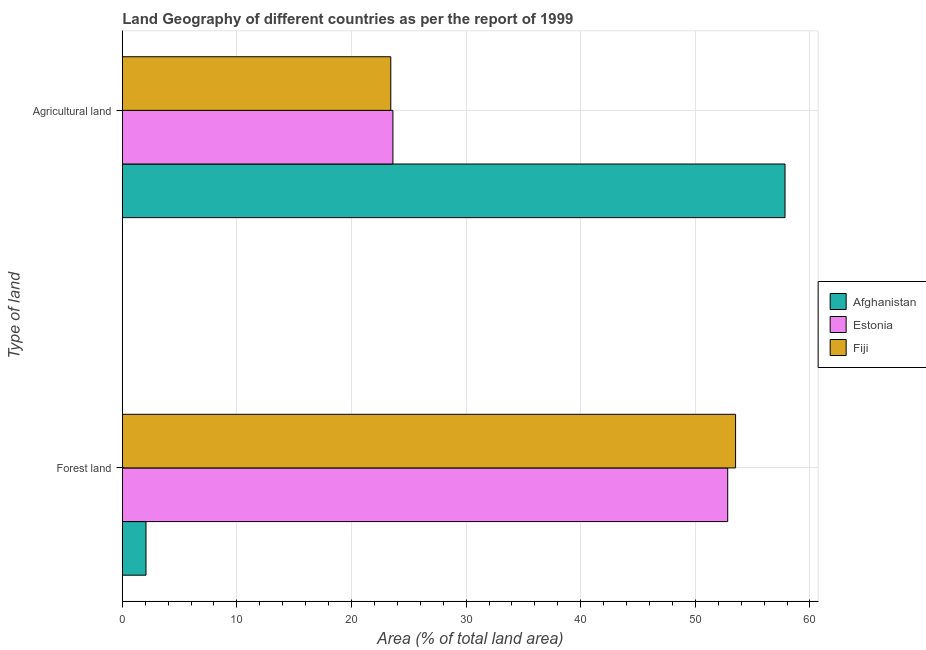Are the number of bars per tick equal to the number of legend labels?
Your answer should be very brief. Yes. Are the number of bars on each tick of the Y-axis equal?
Give a very brief answer. Yes. What is the label of the 1st group of bars from the top?
Give a very brief answer. Agricultural land. What is the percentage of land area under agriculture in Fiji?
Offer a very short reply. 23.43. Across all countries, what is the maximum percentage of land area under forests?
Provide a short and direct response. 53.51. Across all countries, what is the minimum percentage of land area under forests?
Give a very brief answer. 2.07. In which country was the percentage of land area under agriculture maximum?
Your answer should be compact. Afghanistan. In which country was the percentage of land area under forests minimum?
Offer a very short reply. Afghanistan. What is the total percentage of land area under agriculture in the graph?
Provide a succinct answer. 104.87. What is the difference between the percentage of land area under agriculture in Fiji and that in Afghanistan?
Your response must be concise. -34.4. What is the difference between the percentage of land area under agriculture in Fiji and the percentage of land area under forests in Estonia?
Make the answer very short. -29.4. What is the average percentage of land area under forests per country?
Ensure brevity in your answer.  36.14. What is the difference between the percentage of land area under forests and percentage of land area under agriculture in Fiji?
Offer a terse response. 30.09. In how many countries, is the percentage of land area under agriculture greater than 46 %?
Your answer should be very brief. 1. What is the ratio of the percentage of land area under forests in Fiji to that in Afghanistan?
Give a very brief answer. 25.88. In how many countries, is the percentage of land area under agriculture greater than the average percentage of land area under agriculture taken over all countries?
Your answer should be very brief. 1. What does the 1st bar from the top in Forest land represents?
Give a very brief answer. Fiji. What does the 1st bar from the bottom in Agricultural land represents?
Offer a very short reply. Afghanistan. How many bars are there?
Offer a terse response. 6. What is the difference between two consecutive major ticks on the X-axis?
Give a very brief answer. 10. Does the graph contain any zero values?
Offer a terse response. No. Does the graph contain grids?
Your answer should be very brief. Yes. Where does the legend appear in the graph?
Make the answer very short. Center right. How are the legend labels stacked?
Provide a succinct answer. Vertical. What is the title of the graph?
Ensure brevity in your answer.  Land Geography of different countries as per the report of 1999. Does "San Marino" appear as one of the legend labels in the graph?
Your answer should be very brief. No. What is the label or title of the X-axis?
Offer a terse response. Area (% of total land area). What is the label or title of the Y-axis?
Your answer should be very brief. Type of land. What is the Area (% of total land area) in Afghanistan in Forest land?
Make the answer very short. 2.07. What is the Area (% of total land area) of Estonia in Forest land?
Ensure brevity in your answer.  52.83. What is the Area (% of total land area) in Fiji in Forest land?
Keep it short and to the point. 53.51. What is the Area (% of total land area) in Afghanistan in Agricultural land?
Your answer should be very brief. 57.83. What is the Area (% of total land area) of Estonia in Agricultural land?
Provide a succinct answer. 23.61. What is the Area (% of total land area) in Fiji in Agricultural land?
Your answer should be very brief. 23.43. Across all Type of land, what is the maximum Area (% of total land area) of Afghanistan?
Keep it short and to the point. 57.83. Across all Type of land, what is the maximum Area (% of total land area) of Estonia?
Make the answer very short. 52.83. Across all Type of land, what is the maximum Area (% of total land area) of Fiji?
Make the answer very short. 53.51. Across all Type of land, what is the minimum Area (% of total land area) in Afghanistan?
Ensure brevity in your answer.  2.07. Across all Type of land, what is the minimum Area (% of total land area) of Estonia?
Your response must be concise. 23.61. Across all Type of land, what is the minimum Area (% of total land area) in Fiji?
Provide a succinct answer. 23.43. What is the total Area (% of total land area) of Afghanistan in the graph?
Offer a very short reply. 59.89. What is the total Area (% of total land area) in Estonia in the graph?
Offer a very short reply. 76.44. What is the total Area (% of total land area) in Fiji in the graph?
Ensure brevity in your answer.  76.94. What is the difference between the Area (% of total land area) of Afghanistan in Forest land and that in Agricultural land?
Make the answer very short. -55.76. What is the difference between the Area (% of total land area) in Estonia in Forest land and that in Agricultural land?
Provide a short and direct response. 29.21. What is the difference between the Area (% of total land area) in Fiji in Forest land and that in Agricultural land?
Give a very brief answer. 30.09. What is the difference between the Area (% of total land area) in Afghanistan in Forest land and the Area (% of total land area) in Estonia in Agricultural land?
Give a very brief answer. -21.55. What is the difference between the Area (% of total land area) of Afghanistan in Forest land and the Area (% of total land area) of Fiji in Agricultural land?
Keep it short and to the point. -21.36. What is the difference between the Area (% of total land area) in Estonia in Forest land and the Area (% of total land area) in Fiji in Agricultural land?
Ensure brevity in your answer.  29.4. What is the average Area (% of total land area) in Afghanistan per Type of land?
Provide a short and direct response. 29.95. What is the average Area (% of total land area) of Estonia per Type of land?
Offer a very short reply. 38.22. What is the average Area (% of total land area) in Fiji per Type of land?
Offer a terse response. 38.47. What is the difference between the Area (% of total land area) of Afghanistan and Area (% of total land area) of Estonia in Forest land?
Your answer should be very brief. -50.76. What is the difference between the Area (% of total land area) of Afghanistan and Area (% of total land area) of Fiji in Forest land?
Ensure brevity in your answer.  -51.45. What is the difference between the Area (% of total land area) in Estonia and Area (% of total land area) in Fiji in Forest land?
Provide a succinct answer. -0.69. What is the difference between the Area (% of total land area) in Afghanistan and Area (% of total land area) in Estonia in Agricultural land?
Provide a succinct answer. 34.21. What is the difference between the Area (% of total land area) in Afghanistan and Area (% of total land area) in Fiji in Agricultural land?
Make the answer very short. 34.4. What is the difference between the Area (% of total land area) in Estonia and Area (% of total land area) in Fiji in Agricultural land?
Offer a very short reply. 0.19. What is the ratio of the Area (% of total land area) of Afghanistan in Forest land to that in Agricultural land?
Ensure brevity in your answer.  0.04. What is the ratio of the Area (% of total land area) in Estonia in Forest land to that in Agricultural land?
Offer a very short reply. 2.24. What is the ratio of the Area (% of total land area) of Fiji in Forest land to that in Agricultural land?
Give a very brief answer. 2.28. What is the difference between the highest and the second highest Area (% of total land area) of Afghanistan?
Give a very brief answer. 55.76. What is the difference between the highest and the second highest Area (% of total land area) of Estonia?
Ensure brevity in your answer.  29.21. What is the difference between the highest and the second highest Area (% of total land area) of Fiji?
Provide a succinct answer. 30.09. What is the difference between the highest and the lowest Area (% of total land area) in Afghanistan?
Give a very brief answer. 55.76. What is the difference between the highest and the lowest Area (% of total land area) of Estonia?
Keep it short and to the point. 29.21. What is the difference between the highest and the lowest Area (% of total land area) in Fiji?
Your answer should be very brief. 30.09. 